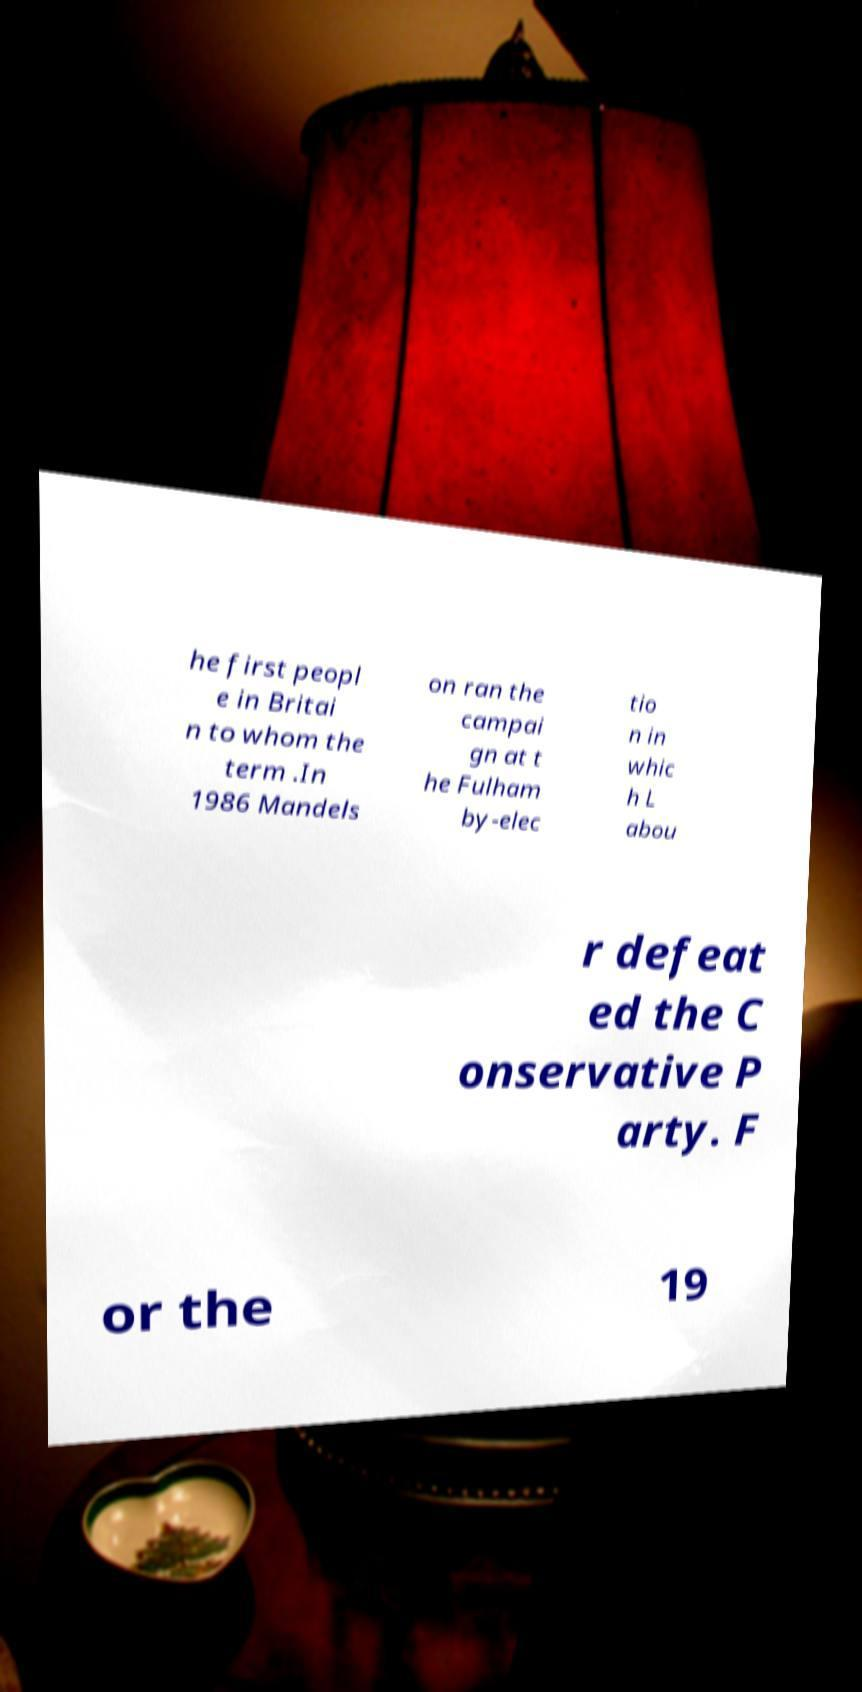Can you read and provide the text displayed in the image?This photo seems to have some interesting text. Can you extract and type it out for me? he first peopl e in Britai n to whom the term .In 1986 Mandels on ran the campai gn at t he Fulham by-elec tio n in whic h L abou r defeat ed the C onservative P arty. F or the 19 